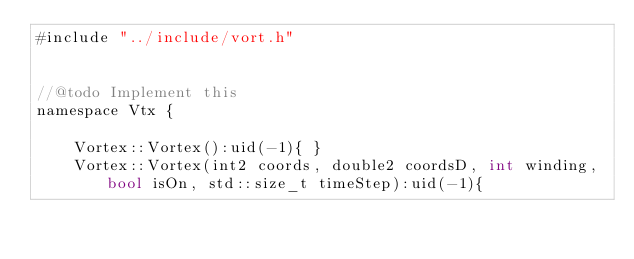Convert code to text. <code><loc_0><loc_0><loc_500><loc_500><_Cuda_>#include "../include/vort.h"


//@todo Implement this
namespace Vtx {

    Vortex::Vortex():uid(-1){ }
    Vortex::Vortex(int2 coords, double2 coordsD, int winding, bool isOn, std::size_t timeStep):uid(-1){</code> 